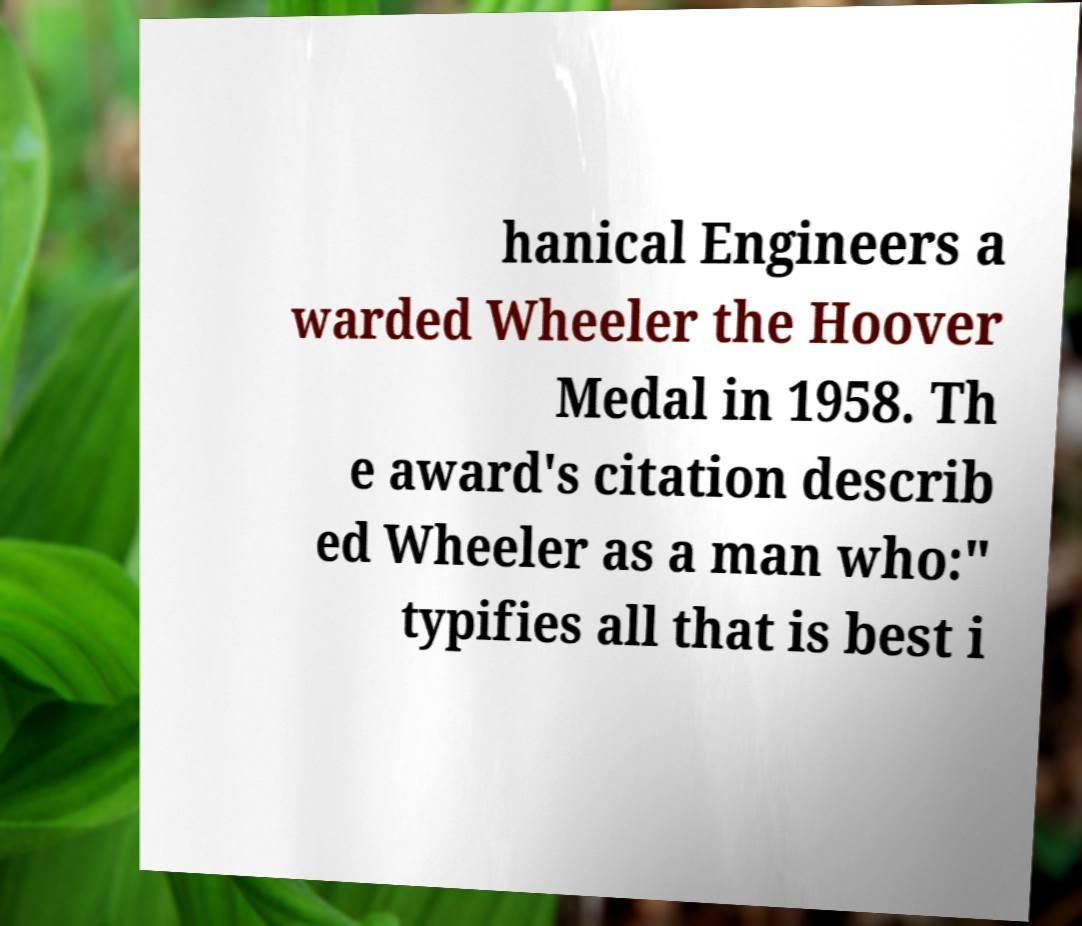Can you accurately transcribe the text from the provided image for me? hanical Engineers a warded Wheeler the Hoover Medal in 1958. Th e award's citation describ ed Wheeler as a man who:" typifies all that is best i 